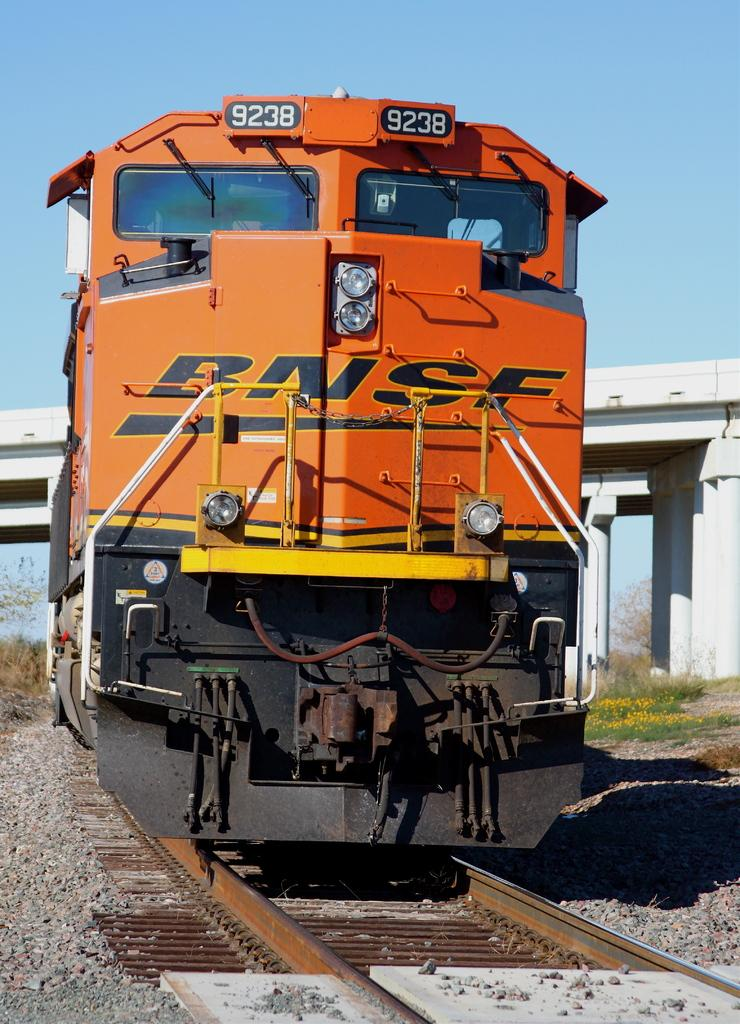What is the main subject of the image? The main subject of the image is a train. Where is the train located in the image? The train is on a railway track. What can be seen in the background of the image? There is a bridge and trees in the background of the image, as well as the sky. How many eyes does the train have in the image? Trains do not have eyes, so this question cannot be answered. 